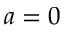<formula> <loc_0><loc_0><loc_500><loc_500>a = 0</formula> 